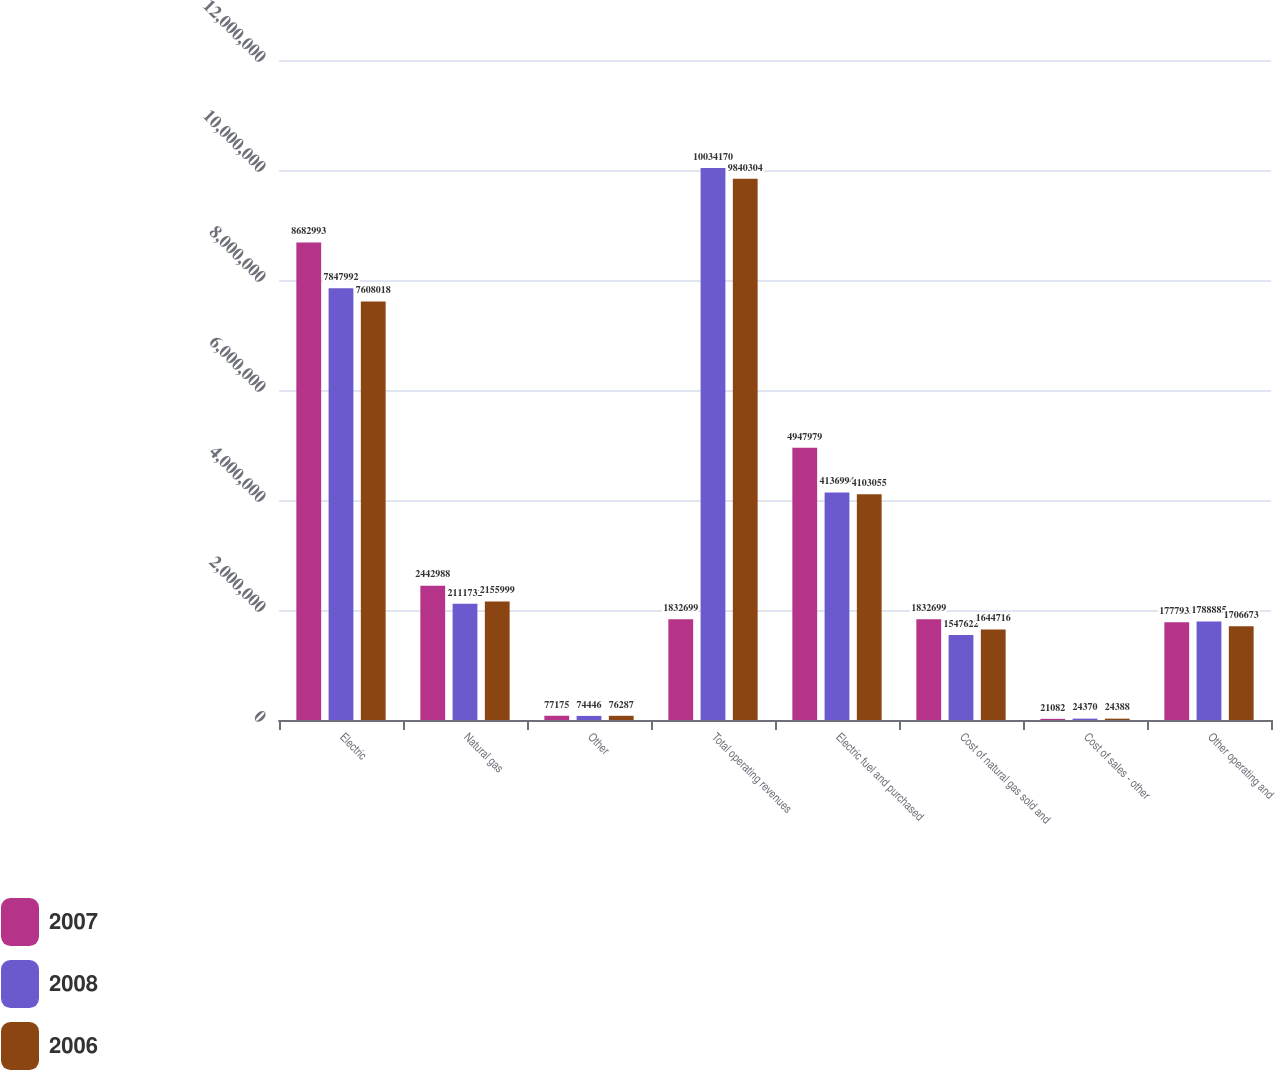Convert chart to OTSL. <chart><loc_0><loc_0><loc_500><loc_500><stacked_bar_chart><ecel><fcel>Electric<fcel>Natural gas<fcel>Other<fcel>Total operating revenues<fcel>Electric fuel and purchased<fcel>Cost of natural gas sold and<fcel>Cost of sales - other<fcel>Other operating and<nl><fcel>2007<fcel>8.68299e+06<fcel>2.44299e+06<fcel>77175<fcel>1.8327e+06<fcel>4.94798e+06<fcel>1.8327e+06<fcel>21082<fcel>1.77793e+06<nl><fcel>2008<fcel>7.84799e+06<fcel>2.11173e+06<fcel>74446<fcel>1.00342e+07<fcel>4.13699e+06<fcel>1.54762e+06<fcel>24370<fcel>1.78888e+06<nl><fcel>2006<fcel>7.60802e+06<fcel>2.156e+06<fcel>76287<fcel>9.8403e+06<fcel>4.10306e+06<fcel>1.64472e+06<fcel>24388<fcel>1.70667e+06<nl></chart> 